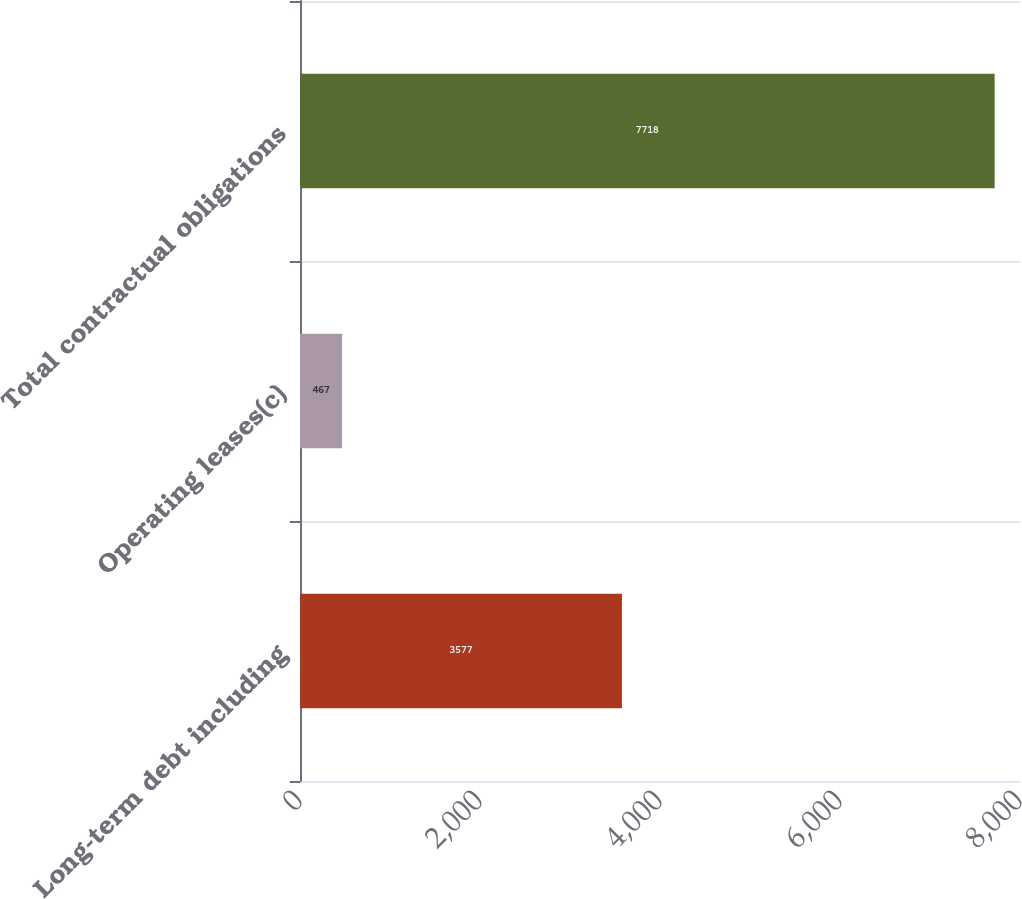Convert chart to OTSL. <chart><loc_0><loc_0><loc_500><loc_500><bar_chart><fcel>Long-term debt including<fcel>Operating leases(c)<fcel>Total contractual obligations<nl><fcel>3577<fcel>467<fcel>7718<nl></chart> 